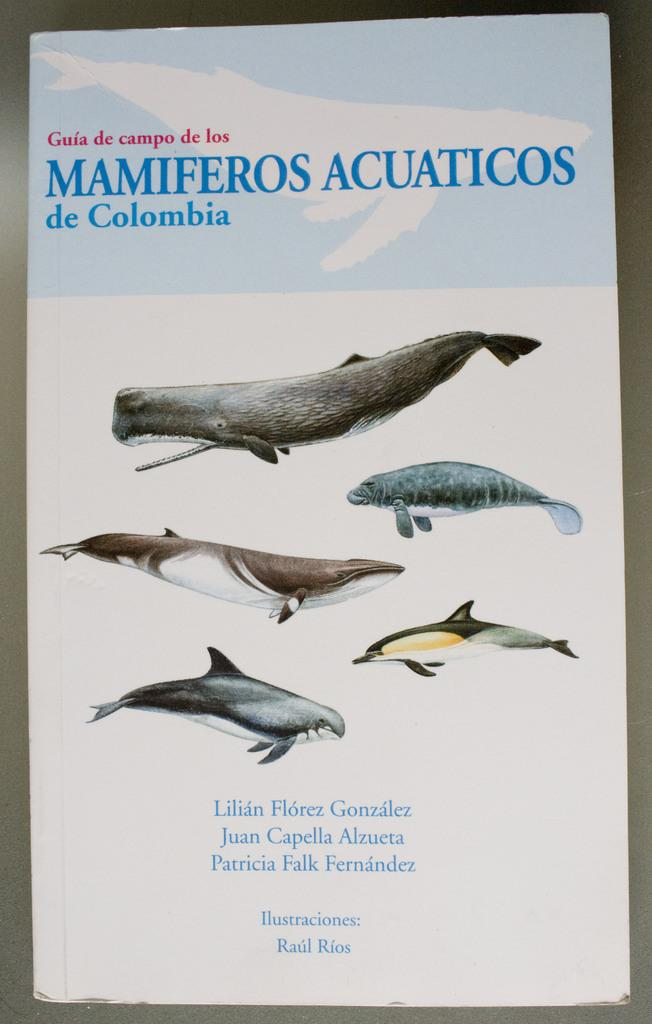What colors are used for the text on the poster? The poster has red and blue color texts. What images can be seen on the poster? The poster contains images of fishes. What is the color of the border on the poster? The poster has a gray color border. What is the color of the background on the poster? The background of the poster is gray in color. Can you see an owl sitting on a branch in the poster? There is no owl or branch present in the poster; it features images of fishes and text in red and blue. 